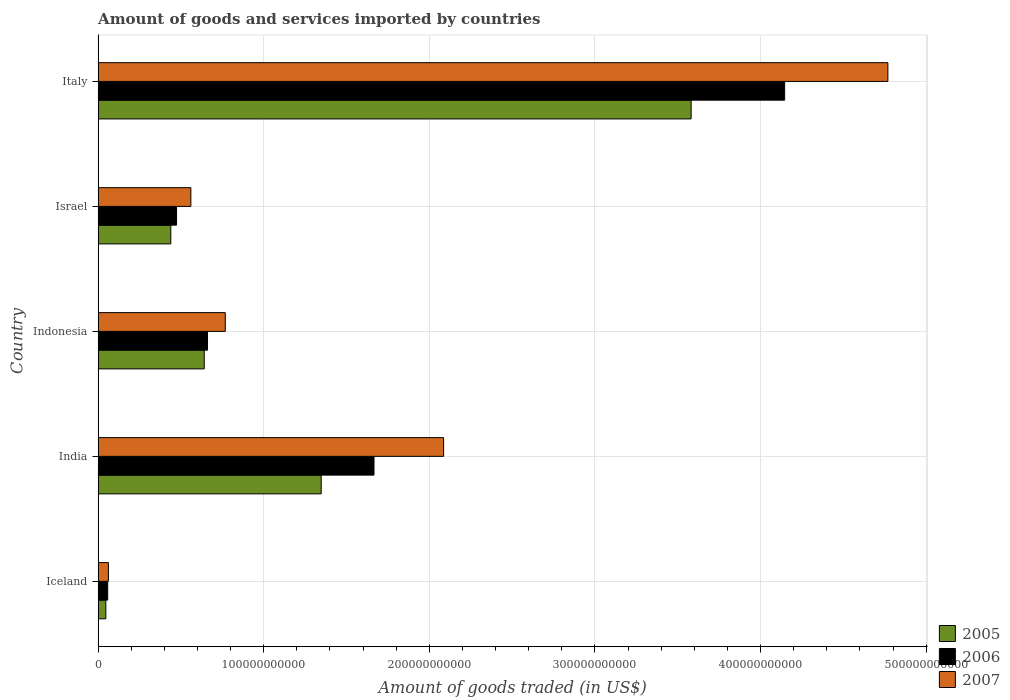How many groups of bars are there?
Keep it short and to the point. 5. Are the number of bars per tick equal to the number of legend labels?
Ensure brevity in your answer.  Yes. Are the number of bars on each tick of the Y-axis equal?
Your answer should be compact. Yes. What is the label of the 1st group of bars from the top?
Give a very brief answer. Italy. What is the total amount of goods and services imported in 2005 in Italy?
Provide a succinct answer. 3.58e+11. Across all countries, what is the maximum total amount of goods and services imported in 2005?
Keep it short and to the point. 3.58e+11. Across all countries, what is the minimum total amount of goods and services imported in 2006?
Ensure brevity in your answer.  5.79e+09. In which country was the total amount of goods and services imported in 2006 minimum?
Keep it short and to the point. Iceland. What is the total total amount of goods and services imported in 2005 in the graph?
Your answer should be compact. 6.05e+11. What is the difference between the total amount of goods and services imported in 2006 in Indonesia and that in Israel?
Provide a short and direct response. 1.87e+1. What is the difference between the total amount of goods and services imported in 2006 in Iceland and the total amount of goods and services imported in 2005 in Indonesia?
Provide a succinct answer. -5.83e+1. What is the average total amount of goods and services imported in 2005 per country?
Your response must be concise. 1.21e+11. What is the difference between the total amount of goods and services imported in 2006 and total amount of goods and services imported in 2005 in Italy?
Your answer should be compact. 5.65e+1. What is the ratio of the total amount of goods and services imported in 2007 in Indonesia to that in Israel?
Your answer should be very brief. 1.37. What is the difference between the highest and the second highest total amount of goods and services imported in 2005?
Offer a terse response. 2.23e+11. What is the difference between the highest and the lowest total amount of goods and services imported in 2005?
Offer a very short reply. 3.53e+11. Is the sum of the total amount of goods and services imported in 2005 in India and Italy greater than the maximum total amount of goods and services imported in 2007 across all countries?
Your answer should be very brief. Yes. What does the 2nd bar from the top in Iceland represents?
Ensure brevity in your answer.  2006. What does the 1st bar from the bottom in Iceland represents?
Your answer should be compact. 2005. Is it the case that in every country, the sum of the total amount of goods and services imported in 2007 and total amount of goods and services imported in 2005 is greater than the total amount of goods and services imported in 2006?
Keep it short and to the point. Yes. What is the difference between two consecutive major ticks on the X-axis?
Provide a succinct answer. 1.00e+11. Does the graph contain any zero values?
Provide a short and direct response. No. Does the graph contain grids?
Provide a short and direct response. Yes. What is the title of the graph?
Make the answer very short. Amount of goods and services imported by countries. What is the label or title of the X-axis?
Your answer should be compact. Amount of goods traded (in US$). What is the Amount of goods traded (in US$) of 2005 in Iceland?
Keep it short and to the point. 4.67e+09. What is the Amount of goods traded (in US$) in 2006 in Iceland?
Provide a short and direct response. 5.79e+09. What is the Amount of goods traded (in US$) in 2007 in Iceland?
Give a very brief answer. 6.21e+09. What is the Amount of goods traded (in US$) in 2005 in India?
Your answer should be very brief. 1.35e+11. What is the Amount of goods traded (in US$) of 2006 in India?
Ensure brevity in your answer.  1.67e+11. What is the Amount of goods traded (in US$) in 2007 in India?
Offer a very short reply. 2.09e+11. What is the Amount of goods traded (in US$) in 2005 in Indonesia?
Provide a short and direct response. 6.41e+1. What is the Amount of goods traded (in US$) in 2006 in Indonesia?
Keep it short and to the point. 6.61e+1. What is the Amount of goods traded (in US$) of 2007 in Indonesia?
Your response must be concise. 7.68e+1. What is the Amount of goods traded (in US$) in 2005 in Israel?
Keep it short and to the point. 4.39e+1. What is the Amount of goods traded (in US$) of 2006 in Israel?
Your response must be concise. 4.73e+1. What is the Amount of goods traded (in US$) in 2007 in Israel?
Ensure brevity in your answer.  5.60e+1. What is the Amount of goods traded (in US$) in 2005 in Italy?
Your answer should be very brief. 3.58e+11. What is the Amount of goods traded (in US$) in 2006 in Italy?
Your response must be concise. 4.15e+11. What is the Amount of goods traded (in US$) in 2007 in Italy?
Ensure brevity in your answer.  4.77e+11. Across all countries, what is the maximum Amount of goods traded (in US$) of 2005?
Offer a terse response. 3.58e+11. Across all countries, what is the maximum Amount of goods traded (in US$) of 2006?
Give a very brief answer. 4.15e+11. Across all countries, what is the maximum Amount of goods traded (in US$) in 2007?
Provide a short and direct response. 4.77e+11. Across all countries, what is the minimum Amount of goods traded (in US$) of 2005?
Your answer should be compact. 4.67e+09. Across all countries, what is the minimum Amount of goods traded (in US$) of 2006?
Provide a succinct answer. 5.79e+09. Across all countries, what is the minimum Amount of goods traded (in US$) of 2007?
Offer a terse response. 6.21e+09. What is the total Amount of goods traded (in US$) of 2005 in the graph?
Offer a very short reply. 6.05e+11. What is the total Amount of goods traded (in US$) in 2006 in the graph?
Make the answer very short. 7.00e+11. What is the total Amount of goods traded (in US$) of 2007 in the graph?
Provide a short and direct response. 8.24e+11. What is the difference between the Amount of goods traded (in US$) of 2005 in Iceland and that in India?
Make the answer very short. -1.30e+11. What is the difference between the Amount of goods traded (in US$) in 2006 in Iceland and that in India?
Offer a very short reply. -1.61e+11. What is the difference between the Amount of goods traded (in US$) of 2007 in Iceland and that in India?
Provide a short and direct response. -2.02e+11. What is the difference between the Amount of goods traded (in US$) of 2005 in Iceland and that in Indonesia?
Ensure brevity in your answer.  -5.94e+1. What is the difference between the Amount of goods traded (in US$) in 2006 in Iceland and that in Indonesia?
Keep it short and to the point. -6.03e+1. What is the difference between the Amount of goods traded (in US$) of 2007 in Iceland and that in Indonesia?
Keep it short and to the point. -7.06e+1. What is the difference between the Amount of goods traded (in US$) of 2005 in Iceland and that in Israel?
Your answer should be very brief. -3.92e+1. What is the difference between the Amount of goods traded (in US$) of 2006 in Iceland and that in Israel?
Give a very brief answer. -4.16e+1. What is the difference between the Amount of goods traded (in US$) of 2007 in Iceland and that in Israel?
Give a very brief answer. -4.98e+1. What is the difference between the Amount of goods traded (in US$) of 2005 in Iceland and that in Italy?
Offer a very short reply. -3.53e+11. What is the difference between the Amount of goods traded (in US$) of 2006 in Iceland and that in Italy?
Your answer should be very brief. -4.09e+11. What is the difference between the Amount of goods traded (in US$) of 2007 in Iceland and that in Italy?
Your answer should be compact. -4.71e+11. What is the difference between the Amount of goods traded (in US$) of 2005 in India and that in Indonesia?
Offer a very short reply. 7.06e+1. What is the difference between the Amount of goods traded (in US$) of 2006 in India and that in Indonesia?
Your answer should be very brief. 1.01e+11. What is the difference between the Amount of goods traded (in US$) in 2007 in India and that in Indonesia?
Your answer should be very brief. 1.32e+11. What is the difference between the Amount of goods traded (in US$) of 2005 in India and that in Israel?
Ensure brevity in your answer.  9.08e+1. What is the difference between the Amount of goods traded (in US$) in 2006 in India and that in Israel?
Offer a terse response. 1.19e+11. What is the difference between the Amount of goods traded (in US$) of 2007 in India and that in Israel?
Provide a short and direct response. 1.53e+11. What is the difference between the Amount of goods traded (in US$) in 2005 in India and that in Italy?
Provide a short and direct response. -2.23e+11. What is the difference between the Amount of goods traded (in US$) in 2006 in India and that in Italy?
Keep it short and to the point. -2.48e+11. What is the difference between the Amount of goods traded (in US$) in 2007 in India and that in Italy?
Give a very brief answer. -2.68e+11. What is the difference between the Amount of goods traded (in US$) in 2005 in Indonesia and that in Israel?
Offer a very short reply. 2.02e+1. What is the difference between the Amount of goods traded (in US$) in 2006 in Indonesia and that in Israel?
Your answer should be very brief. 1.87e+1. What is the difference between the Amount of goods traded (in US$) of 2007 in Indonesia and that in Israel?
Offer a very short reply. 2.08e+1. What is the difference between the Amount of goods traded (in US$) of 2005 in Indonesia and that in Italy?
Your answer should be very brief. -2.94e+11. What is the difference between the Amount of goods traded (in US$) of 2006 in Indonesia and that in Italy?
Provide a short and direct response. -3.48e+11. What is the difference between the Amount of goods traded (in US$) in 2007 in Indonesia and that in Italy?
Your answer should be very brief. -4.00e+11. What is the difference between the Amount of goods traded (in US$) in 2005 in Israel and that in Italy?
Your answer should be compact. -3.14e+11. What is the difference between the Amount of goods traded (in US$) of 2006 in Israel and that in Italy?
Provide a short and direct response. -3.67e+11. What is the difference between the Amount of goods traded (in US$) in 2007 in Israel and that in Italy?
Offer a terse response. -4.21e+11. What is the difference between the Amount of goods traded (in US$) in 2005 in Iceland and the Amount of goods traded (in US$) in 2006 in India?
Offer a very short reply. -1.62e+11. What is the difference between the Amount of goods traded (in US$) in 2005 in Iceland and the Amount of goods traded (in US$) in 2007 in India?
Offer a terse response. -2.04e+11. What is the difference between the Amount of goods traded (in US$) in 2006 in Iceland and the Amount of goods traded (in US$) in 2007 in India?
Offer a very short reply. -2.03e+11. What is the difference between the Amount of goods traded (in US$) of 2005 in Iceland and the Amount of goods traded (in US$) of 2006 in Indonesia?
Your answer should be compact. -6.14e+1. What is the difference between the Amount of goods traded (in US$) in 2005 in Iceland and the Amount of goods traded (in US$) in 2007 in Indonesia?
Provide a succinct answer. -7.21e+1. What is the difference between the Amount of goods traded (in US$) in 2006 in Iceland and the Amount of goods traded (in US$) in 2007 in Indonesia?
Provide a succinct answer. -7.10e+1. What is the difference between the Amount of goods traded (in US$) in 2005 in Iceland and the Amount of goods traded (in US$) in 2006 in Israel?
Provide a short and direct response. -4.27e+1. What is the difference between the Amount of goods traded (in US$) of 2005 in Iceland and the Amount of goods traded (in US$) of 2007 in Israel?
Give a very brief answer. -5.13e+1. What is the difference between the Amount of goods traded (in US$) of 2006 in Iceland and the Amount of goods traded (in US$) of 2007 in Israel?
Provide a short and direct response. -5.02e+1. What is the difference between the Amount of goods traded (in US$) of 2005 in Iceland and the Amount of goods traded (in US$) of 2006 in Italy?
Give a very brief answer. -4.10e+11. What is the difference between the Amount of goods traded (in US$) in 2005 in Iceland and the Amount of goods traded (in US$) in 2007 in Italy?
Your answer should be compact. -4.72e+11. What is the difference between the Amount of goods traded (in US$) in 2006 in Iceland and the Amount of goods traded (in US$) in 2007 in Italy?
Keep it short and to the point. -4.71e+11. What is the difference between the Amount of goods traded (in US$) of 2005 in India and the Amount of goods traded (in US$) of 2006 in Indonesia?
Provide a succinct answer. 6.86e+1. What is the difference between the Amount of goods traded (in US$) of 2005 in India and the Amount of goods traded (in US$) of 2007 in Indonesia?
Give a very brief answer. 5.79e+1. What is the difference between the Amount of goods traded (in US$) in 2006 in India and the Amount of goods traded (in US$) in 2007 in Indonesia?
Keep it short and to the point. 8.98e+1. What is the difference between the Amount of goods traded (in US$) in 2005 in India and the Amount of goods traded (in US$) in 2006 in Israel?
Give a very brief answer. 8.73e+1. What is the difference between the Amount of goods traded (in US$) in 2005 in India and the Amount of goods traded (in US$) in 2007 in Israel?
Make the answer very short. 7.87e+1. What is the difference between the Amount of goods traded (in US$) in 2006 in India and the Amount of goods traded (in US$) in 2007 in Israel?
Offer a terse response. 1.11e+11. What is the difference between the Amount of goods traded (in US$) of 2005 in India and the Amount of goods traded (in US$) of 2006 in Italy?
Make the answer very short. -2.80e+11. What is the difference between the Amount of goods traded (in US$) of 2005 in India and the Amount of goods traded (in US$) of 2007 in Italy?
Your answer should be compact. -3.42e+11. What is the difference between the Amount of goods traded (in US$) of 2006 in India and the Amount of goods traded (in US$) of 2007 in Italy?
Your answer should be compact. -3.10e+11. What is the difference between the Amount of goods traded (in US$) of 2005 in Indonesia and the Amount of goods traded (in US$) of 2006 in Israel?
Offer a terse response. 1.67e+1. What is the difference between the Amount of goods traded (in US$) of 2005 in Indonesia and the Amount of goods traded (in US$) of 2007 in Israel?
Make the answer very short. 8.07e+09. What is the difference between the Amount of goods traded (in US$) of 2006 in Indonesia and the Amount of goods traded (in US$) of 2007 in Israel?
Your answer should be compact. 1.01e+1. What is the difference between the Amount of goods traded (in US$) in 2005 in Indonesia and the Amount of goods traded (in US$) in 2006 in Italy?
Provide a succinct answer. -3.50e+11. What is the difference between the Amount of goods traded (in US$) in 2005 in Indonesia and the Amount of goods traded (in US$) in 2007 in Italy?
Your answer should be compact. -4.13e+11. What is the difference between the Amount of goods traded (in US$) in 2006 in Indonesia and the Amount of goods traded (in US$) in 2007 in Italy?
Ensure brevity in your answer.  -4.11e+11. What is the difference between the Amount of goods traded (in US$) of 2005 in Israel and the Amount of goods traded (in US$) of 2006 in Italy?
Provide a short and direct response. -3.71e+11. What is the difference between the Amount of goods traded (in US$) of 2005 in Israel and the Amount of goods traded (in US$) of 2007 in Italy?
Provide a succinct answer. -4.33e+11. What is the difference between the Amount of goods traded (in US$) of 2006 in Israel and the Amount of goods traded (in US$) of 2007 in Italy?
Provide a succinct answer. -4.30e+11. What is the average Amount of goods traded (in US$) in 2005 per country?
Offer a very short reply. 1.21e+11. What is the average Amount of goods traded (in US$) of 2006 per country?
Provide a short and direct response. 1.40e+11. What is the average Amount of goods traded (in US$) in 2007 per country?
Provide a succinct answer. 1.65e+11. What is the difference between the Amount of goods traded (in US$) in 2005 and Amount of goods traded (in US$) in 2006 in Iceland?
Make the answer very short. -1.12e+09. What is the difference between the Amount of goods traded (in US$) in 2005 and Amount of goods traded (in US$) in 2007 in Iceland?
Provide a short and direct response. -1.54e+09. What is the difference between the Amount of goods traded (in US$) in 2006 and Amount of goods traded (in US$) in 2007 in Iceland?
Give a very brief answer. -4.23e+08. What is the difference between the Amount of goods traded (in US$) in 2005 and Amount of goods traded (in US$) in 2006 in India?
Provide a short and direct response. -3.19e+1. What is the difference between the Amount of goods traded (in US$) of 2005 and Amount of goods traded (in US$) of 2007 in India?
Give a very brief answer. -7.39e+1. What is the difference between the Amount of goods traded (in US$) of 2006 and Amount of goods traded (in US$) of 2007 in India?
Your answer should be compact. -4.20e+1. What is the difference between the Amount of goods traded (in US$) in 2005 and Amount of goods traded (in US$) in 2006 in Indonesia?
Provide a short and direct response. -1.98e+09. What is the difference between the Amount of goods traded (in US$) of 2005 and Amount of goods traded (in US$) of 2007 in Indonesia?
Keep it short and to the point. -1.27e+1. What is the difference between the Amount of goods traded (in US$) in 2006 and Amount of goods traded (in US$) in 2007 in Indonesia?
Offer a terse response. -1.07e+1. What is the difference between the Amount of goods traded (in US$) of 2005 and Amount of goods traded (in US$) of 2006 in Israel?
Offer a very short reply. -3.46e+09. What is the difference between the Amount of goods traded (in US$) of 2005 and Amount of goods traded (in US$) of 2007 in Israel?
Make the answer very short. -1.21e+1. What is the difference between the Amount of goods traded (in US$) of 2006 and Amount of goods traded (in US$) of 2007 in Israel?
Keep it short and to the point. -8.65e+09. What is the difference between the Amount of goods traded (in US$) of 2005 and Amount of goods traded (in US$) of 2006 in Italy?
Give a very brief answer. -5.65e+1. What is the difference between the Amount of goods traded (in US$) in 2005 and Amount of goods traded (in US$) in 2007 in Italy?
Your answer should be compact. -1.19e+11. What is the difference between the Amount of goods traded (in US$) in 2006 and Amount of goods traded (in US$) in 2007 in Italy?
Your answer should be compact. -6.23e+1. What is the ratio of the Amount of goods traded (in US$) in 2005 in Iceland to that in India?
Offer a terse response. 0.03. What is the ratio of the Amount of goods traded (in US$) in 2006 in Iceland to that in India?
Offer a very short reply. 0.03. What is the ratio of the Amount of goods traded (in US$) in 2007 in Iceland to that in India?
Provide a short and direct response. 0.03. What is the ratio of the Amount of goods traded (in US$) of 2005 in Iceland to that in Indonesia?
Your response must be concise. 0.07. What is the ratio of the Amount of goods traded (in US$) in 2006 in Iceland to that in Indonesia?
Make the answer very short. 0.09. What is the ratio of the Amount of goods traded (in US$) in 2007 in Iceland to that in Indonesia?
Your answer should be compact. 0.08. What is the ratio of the Amount of goods traded (in US$) in 2005 in Iceland to that in Israel?
Your answer should be compact. 0.11. What is the ratio of the Amount of goods traded (in US$) in 2006 in Iceland to that in Israel?
Your answer should be very brief. 0.12. What is the ratio of the Amount of goods traded (in US$) of 2007 in Iceland to that in Israel?
Offer a terse response. 0.11. What is the ratio of the Amount of goods traded (in US$) in 2005 in Iceland to that in Italy?
Your response must be concise. 0.01. What is the ratio of the Amount of goods traded (in US$) of 2006 in Iceland to that in Italy?
Make the answer very short. 0.01. What is the ratio of the Amount of goods traded (in US$) in 2007 in Iceland to that in Italy?
Ensure brevity in your answer.  0.01. What is the ratio of the Amount of goods traded (in US$) of 2005 in India to that in Indonesia?
Your answer should be very brief. 2.1. What is the ratio of the Amount of goods traded (in US$) of 2006 in India to that in Indonesia?
Provide a short and direct response. 2.52. What is the ratio of the Amount of goods traded (in US$) of 2007 in India to that in Indonesia?
Offer a terse response. 2.72. What is the ratio of the Amount of goods traded (in US$) in 2005 in India to that in Israel?
Give a very brief answer. 3.07. What is the ratio of the Amount of goods traded (in US$) of 2006 in India to that in Israel?
Your response must be concise. 3.52. What is the ratio of the Amount of goods traded (in US$) of 2007 in India to that in Israel?
Your answer should be compact. 3.73. What is the ratio of the Amount of goods traded (in US$) of 2005 in India to that in Italy?
Your answer should be compact. 0.38. What is the ratio of the Amount of goods traded (in US$) in 2006 in India to that in Italy?
Give a very brief answer. 0.4. What is the ratio of the Amount of goods traded (in US$) of 2007 in India to that in Italy?
Offer a terse response. 0.44. What is the ratio of the Amount of goods traded (in US$) of 2005 in Indonesia to that in Israel?
Make the answer very short. 1.46. What is the ratio of the Amount of goods traded (in US$) of 2006 in Indonesia to that in Israel?
Offer a terse response. 1.4. What is the ratio of the Amount of goods traded (in US$) in 2007 in Indonesia to that in Israel?
Your response must be concise. 1.37. What is the ratio of the Amount of goods traded (in US$) of 2005 in Indonesia to that in Italy?
Keep it short and to the point. 0.18. What is the ratio of the Amount of goods traded (in US$) of 2006 in Indonesia to that in Italy?
Your answer should be very brief. 0.16. What is the ratio of the Amount of goods traded (in US$) of 2007 in Indonesia to that in Italy?
Provide a short and direct response. 0.16. What is the ratio of the Amount of goods traded (in US$) of 2005 in Israel to that in Italy?
Offer a terse response. 0.12. What is the ratio of the Amount of goods traded (in US$) of 2006 in Israel to that in Italy?
Your answer should be very brief. 0.11. What is the ratio of the Amount of goods traded (in US$) in 2007 in Israel to that in Italy?
Your answer should be very brief. 0.12. What is the difference between the highest and the second highest Amount of goods traded (in US$) of 2005?
Keep it short and to the point. 2.23e+11. What is the difference between the highest and the second highest Amount of goods traded (in US$) of 2006?
Your answer should be very brief. 2.48e+11. What is the difference between the highest and the second highest Amount of goods traded (in US$) of 2007?
Offer a very short reply. 2.68e+11. What is the difference between the highest and the lowest Amount of goods traded (in US$) in 2005?
Provide a succinct answer. 3.53e+11. What is the difference between the highest and the lowest Amount of goods traded (in US$) of 2006?
Provide a short and direct response. 4.09e+11. What is the difference between the highest and the lowest Amount of goods traded (in US$) in 2007?
Your response must be concise. 4.71e+11. 